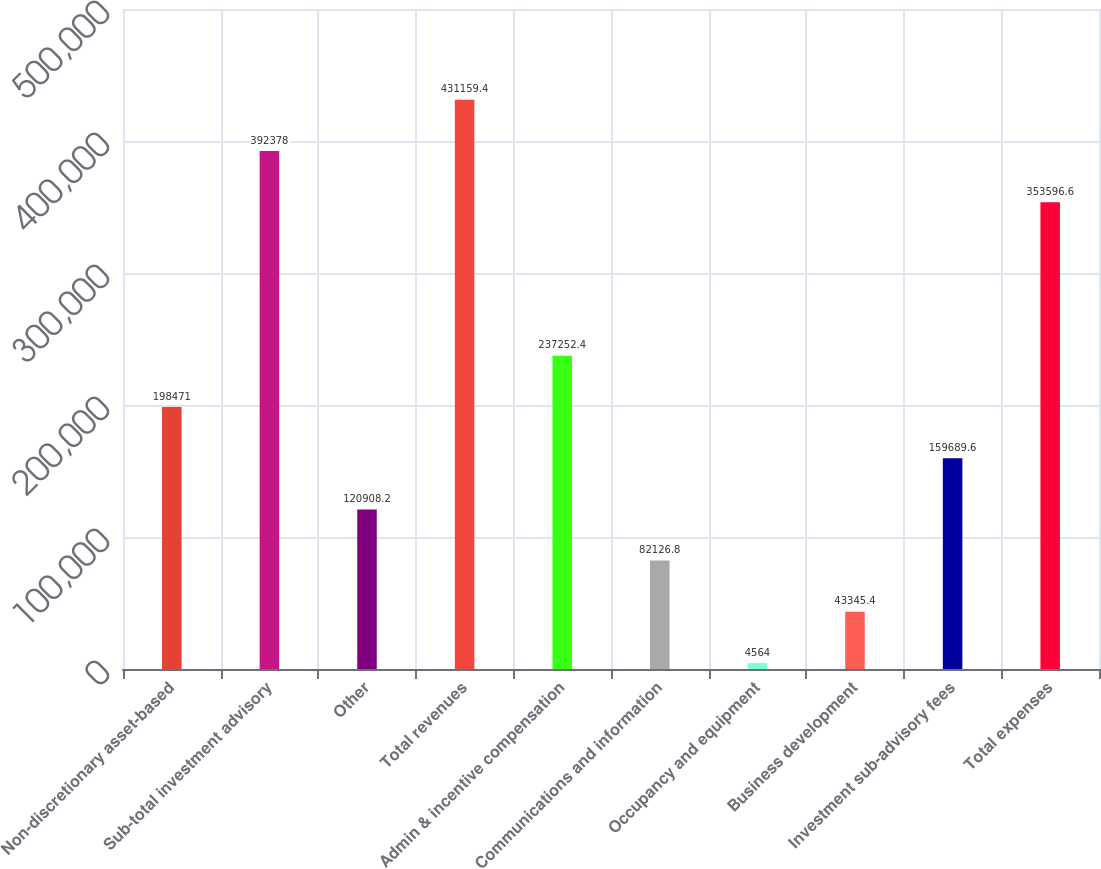Convert chart. <chart><loc_0><loc_0><loc_500><loc_500><bar_chart><fcel>Non-discretionary asset-based<fcel>Sub-total investment advisory<fcel>Other<fcel>Total revenues<fcel>Admin & incentive compensation<fcel>Communications and information<fcel>Occupancy and equipment<fcel>Business development<fcel>Investment sub-advisory fees<fcel>Total expenses<nl><fcel>198471<fcel>392378<fcel>120908<fcel>431159<fcel>237252<fcel>82126.8<fcel>4564<fcel>43345.4<fcel>159690<fcel>353597<nl></chart> 